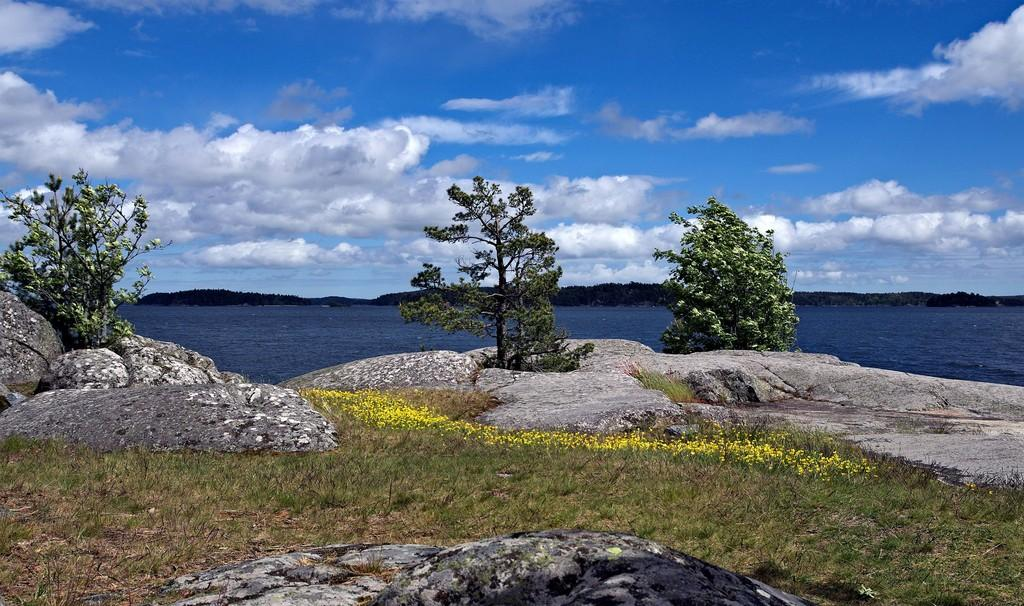What is the primary element in the image? The image consists of water. What can be found at the bottom of the water? There are rocks at the bottom of the image. What type of vegetation is present on the ground? Green grass is present on the ground. What is located in the middle of the image? There are trees in the middle of the image. What is visible in the sky at the top of the image? Clouds are visible in the sky at the top of the image. Where is the sofa located in the image? There is no sofa present in the image. What type of sun can be seen in the image? There is no sun visible in the image; only clouds are present in the sky. 